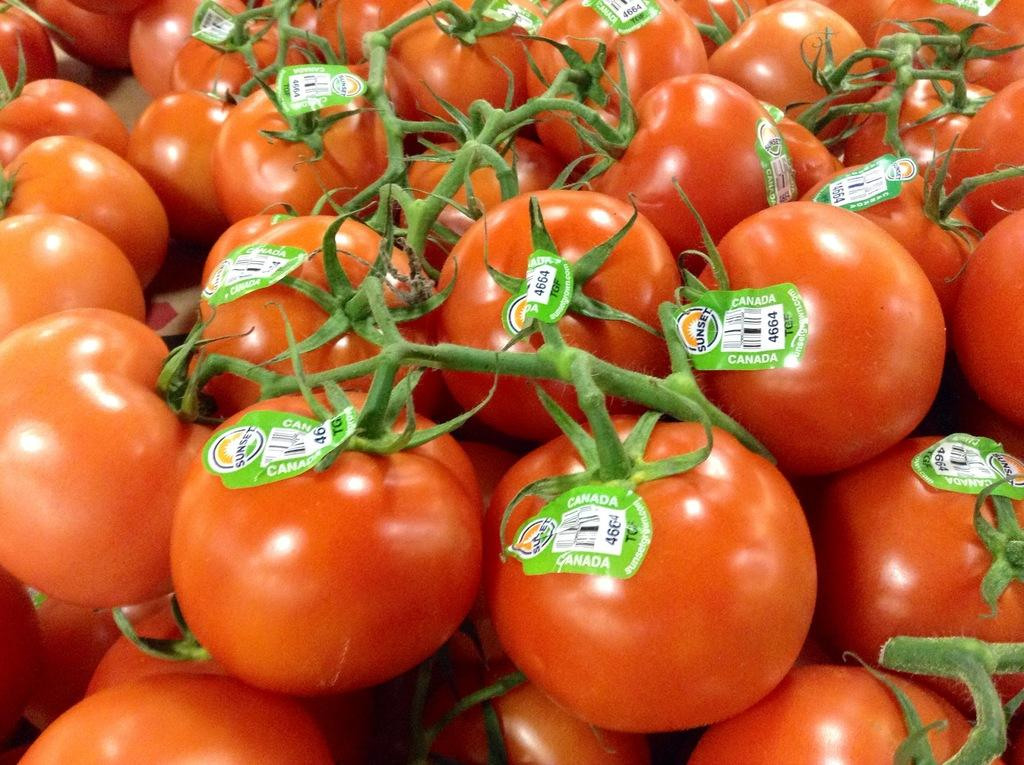What is the main subject of the image? The main subject of the image is a lot of tomatoes. Are there any additional features or elements on the tomatoes? Yes, there are stickers attached to each tomato. Where is the farmer standing in the image? There is no farmer present in the image. What type of duck can be seen swimming in the middle of the tomatoes? There are no ducks present in the image, and the tomatoes are not depicted in a way that would allow a duck to swim among them. 